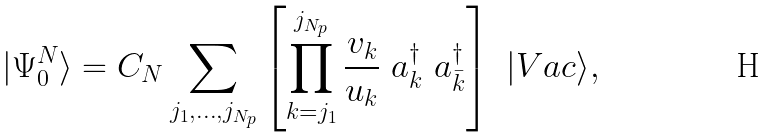Convert formula to latex. <formula><loc_0><loc_0><loc_500><loc_500>| \Psi _ { 0 } ^ { N } \rangle = C _ { N } \sum _ { j _ { 1 } , \dots , j _ { N _ { p } } } \left [ \prod _ { k = j _ { 1 } } ^ { j _ { N _ { p } } } \frac { v _ { k } } { u _ { k } } \ a _ { k } ^ { \dagger } \ a _ { \bar { k } } ^ { \dagger } \right ] \ | V a c \rangle ,</formula> 